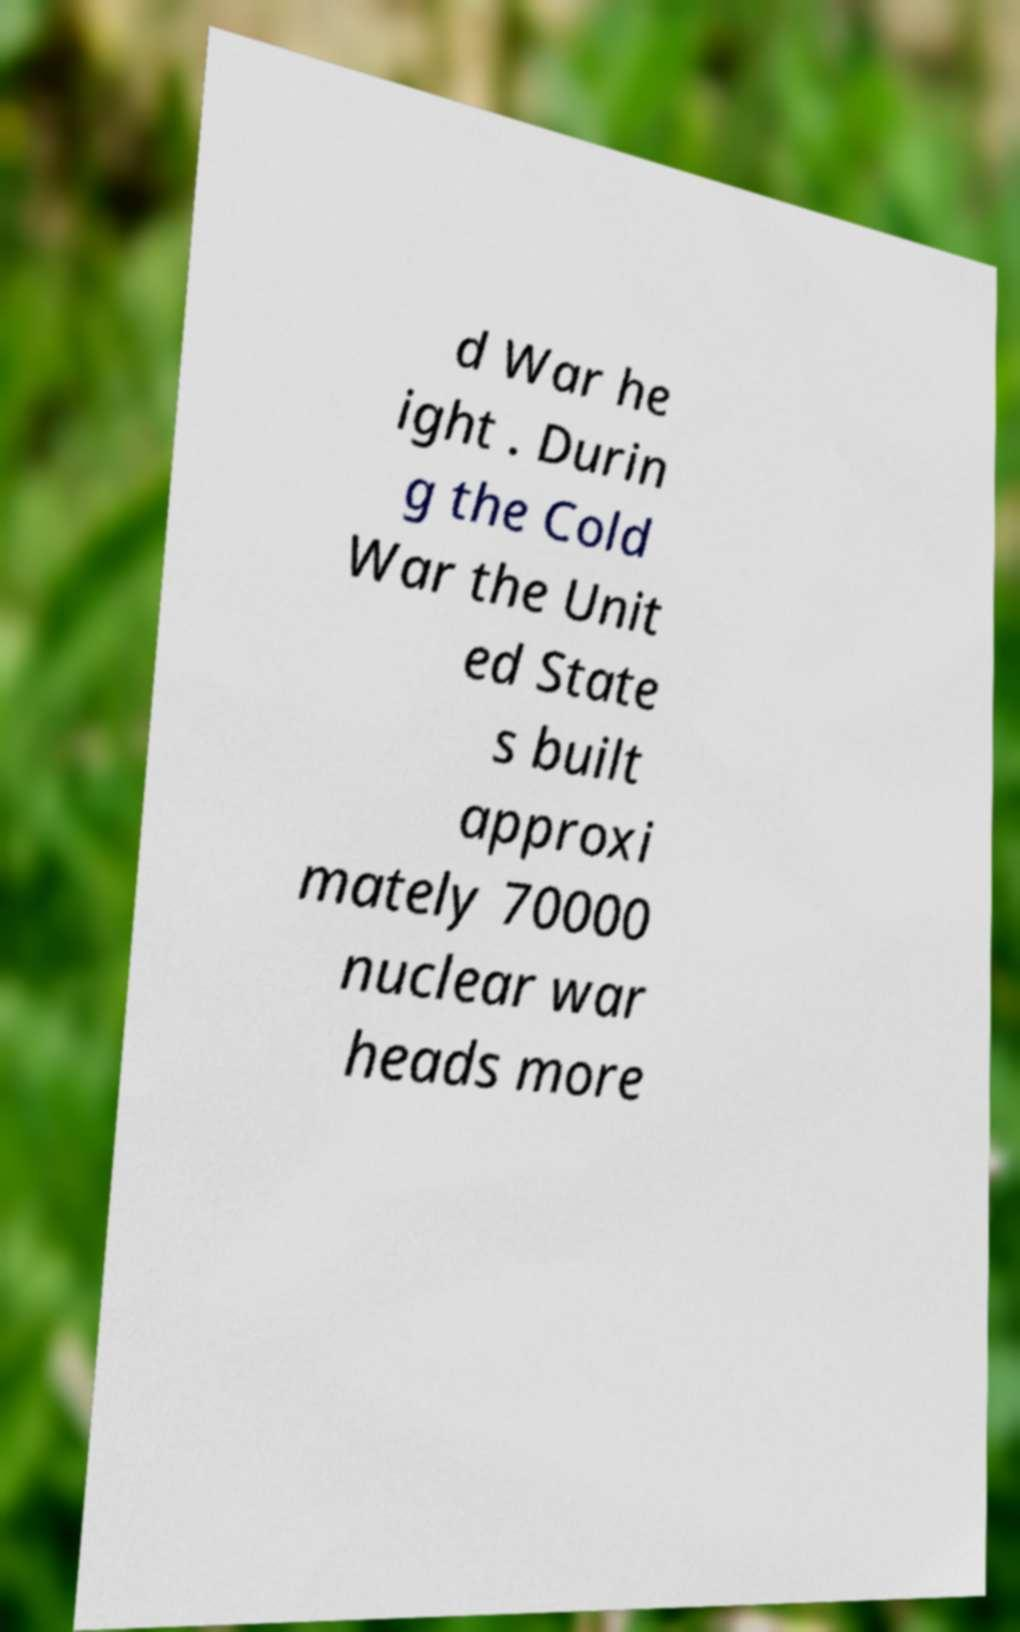Can you accurately transcribe the text from the provided image for me? d War he ight . Durin g the Cold War the Unit ed State s built approxi mately 70000 nuclear war heads more 